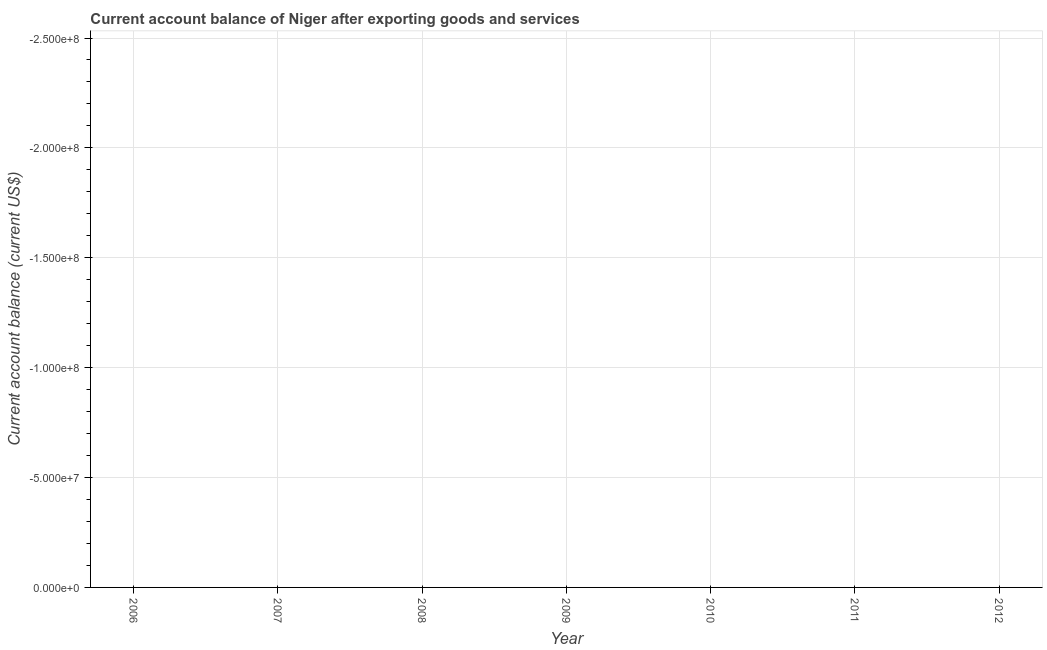What is the sum of the current account balance?
Offer a terse response. 0. What is the average current account balance per year?
Keep it short and to the point. 0. In how many years, is the current account balance greater than the average current account balance taken over all years?
Ensure brevity in your answer.  0. How many years are there in the graph?
Your answer should be compact. 7. What is the difference between two consecutive major ticks on the Y-axis?
Offer a terse response. 5.00e+07. Are the values on the major ticks of Y-axis written in scientific E-notation?
Offer a terse response. Yes. Does the graph contain any zero values?
Make the answer very short. Yes. What is the title of the graph?
Make the answer very short. Current account balance of Niger after exporting goods and services. What is the label or title of the Y-axis?
Make the answer very short. Current account balance (current US$). What is the Current account balance (current US$) in 2007?
Offer a terse response. 0. What is the Current account balance (current US$) in 2008?
Give a very brief answer. 0. What is the Current account balance (current US$) in 2009?
Keep it short and to the point. 0. What is the Current account balance (current US$) in 2012?
Your response must be concise. 0. 